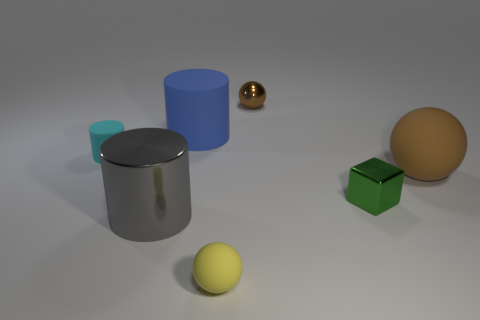Subtract all cyan blocks. How many brown spheres are left? 2 Subtract all cyan cylinders. How many cylinders are left? 2 Subtract all rubber cylinders. How many cylinders are left? 1 Subtract all brown balls. How many were subtracted if there are1brown balls left? 1 Subtract 2 spheres. How many spheres are left? 1 Subtract all gray cubes. Subtract all red spheres. How many cubes are left? 1 Subtract all big gray things. Subtract all big gray cylinders. How many objects are left? 5 Add 1 green blocks. How many green blocks are left? 2 Add 1 cyan cubes. How many cyan cubes exist? 1 Add 3 small brown rubber spheres. How many objects exist? 10 